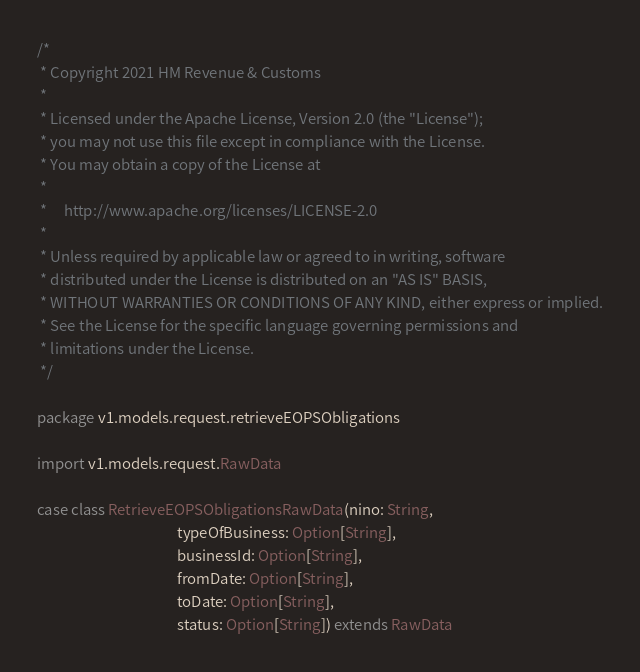<code> <loc_0><loc_0><loc_500><loc_500><_Scala_>/*
 * Copyright 2021 HM Revenue & Customs
 *
 * Licensed under the Apache License, Version 2.0 (the "License");
 * you may not use this file except in compliance with the License.
 * You may obtain a copy of the License at
 *
 *     http://www.apache.org/licenses/LICENSE-2.0
 *
 * Unless required by applicable law or agreed to in writing, software
 * distributed under the License is distributed on an "AS IS" BASIS,
 * WITHOUT WARRANTIES OR CONDITIONS OF ANY KIND, either express or implied.
 * See the License for the specific language governing permissions and
 * limitations under the License.
 */

package v1.models.request.retrieveEOPSObligations

import v1.models.request.RawData

case class RetrieveEOPSObligationsRawData(nino: String,
                                          typeOfBusiness: Option[String],
                                          businessId: Option[String],
                                          fromDate: Option[String],
                                          toDate: Option[String],
                                          status: Option[String]) extends RawData
</code> 